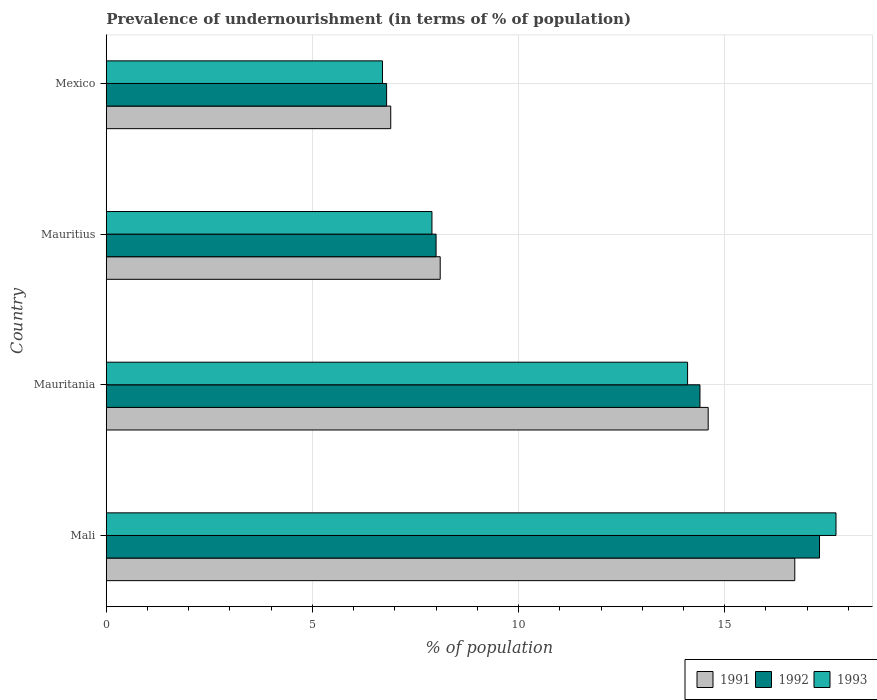How many different coloured bars are there?
Give a very brief answer. 3. How many groups of bars are there?
Offer a very short reply. 4. How many bars are there on the 4th tick from the bottom?
Provide a short and direct response. 3. What is the label of the 3rd group of bars from the top?
Provide a succinct answer. Mauritania. In which country was the percentage of undernourished population in 1992 maximum?
Your response must be concise. Mali. What is the total percentage of undernourished population in 1991 in the graph?
Your answer should be compact. 46.3. What is the difference between the percentage of undernourished population in 1992 in Mexico and the percentage of undernourished population in 1993 in Mali?
Provide a succinct answer. -10.9. What is the average percentage of undernourished population in 1992 per country?
Your answer should be very brief. 11.62. What is the difference between the percentage of undernourished population in 1993 and percentage of undernourished population in 1991 in Mexico?
Keep it short and to the point. -0.2. What is the ratio of the percentage of undernourished population in 1993 in Mali to that in Mauritius?
Offer a terse response. 2.24. Is the difference between the percentage of undernourished population in 1993 in Mali and Mauritius greater than the difference between the percentage of undernourished population in 1991 in Mali and Mauritius?
Ensure brevity in your answer.  Yes. What is the difference between the highest and the second highest percentage of undernourished population in 1993?
Give a very brief answer. 3.6. What is the difference between the highest and the lowest percentage of undernourished population in 1993?
Provide a short and direct response. 11. Is it the case that in every country, the sum of the percentage of undernourished population in 1991 and percentage of undernourished population in 1993 is greater than the percentage of undernourished population in 1992?
Your answer should be very brief. Yes. How many countries are there in the graph?
Make the answer very short. 4. What is the difference between two consecutive major ticks on the X-axis?
Provide a short and direct response. 5. How many legend labels are there?
Your answer should be compact. 3. How are the legend labels stacked?
Your response must be concise. Horizontal. What is the title of the graph?
Give a very brief answer. Prevalence of undernourishment (in terms of % of population). What is the label or title of the X-axis?
Your answer should be very brief. % of population. What is the label or title of the Y-axis?
Give a very brief answer. Country. What is the % of population of 1991 in Mali?
Keep it short and to the point. 16.7. What is the % of population in 1993 in Mali?
Your answer should be compact. 17.7. What is the % of population of 1991 in Mauritania?
Keep it short and to the point. 14.6. What is the % of population of 1993 in Mauritius?
Ensure brevity in your answer.  7.9. What is the % of population in 1991 in Mexico?
Ensure brevity in your answer.  6.9. What is the % of population of 1992 in Mexico?
Keep it short and to the point. 6.8. What is the % of population of 1993 in Mexico?
Your answer should be very brief. 6.7. Across all countries, what is the maximum % of population in 1991?
Provide a short and direct response. 16.7. What is the total % of population of 1991 in the graph?
Offer a terse response. 46.3. What is the total % of population in 1992 in the graph?
Provide a succinct answer. 46.5. What is the total % of population in 1993 in the graph?
Ensure brevity in your answer.  46.4. What is the difference between the % of population in 1993 in Mali and that in Mauritania?
Provide a succinct answer. 3.6. What is the difference between the % of population of 1991 in Mali and that in Mauritius?
Provide a short and direct response. 8.6. What is the difference between the % of population in 1992 in Mali and that in Mauritius?
Provide a short and direct response. 9.3. What is the difference between the % of population in 1992 in Mauritania and that in Mexico?
Make the answer very short. 7.6. What is the difference between the % of population of 1991 in Mauritius and that in Mexico?
Provide a succinct answer. 1.2. What is the difference between the % of population of 1992 in Mauritius and that in Mexico?
Make the answer very short. 1.2. What is the difference between the % of population in 1993 in Mauritius and that in Mexico?
Keep it short and to the point. 1.2. What is the difference between the % of population of 1991 in Mali and the % of population of 1992 in Mauritania?
Offer a terse response. 2.3. What is the difference between the % of population in 1991 in Mali and the % of population in 1993 in Mauritania?
Your answer should be very brief. 2.6. What is the difference between the % of population of 1992 in Mali and the % of population of 1993 in Mauritania?
Provide a short and direct response. 3.2. What is the difference between the % of population of 1991 in Mali and the % of population of 1993 in Mauritius?
Keep it short and to the point. 8.8. What is the difference between the % of population of 1991 in Mali and the % of population of 1992 in Mexico?
Your answer should be compact. 9.9. What is the difference between the % of population in 1991 in Mali and the % of population in 1993 in Mexico?
Offer a terse response. 10. What is the difference between the % of population in 1991 in Mauritania and the % of population in 1992 in Mauritius?
Offer a terse response. 6.6. What is the difference between the % of population in 1992 in Mauritania and the % of population in 1993 in Mauritius?
Your answer should be very brief. 6.5. What is the difference between the % of population in 1991 in Mauritania and the % of population in 1992 in Mexico?
Keep it short and to the point. 7.8. What is the difference between the % of population in 1992 in Mauritania and the % of population in 1993 in Mexico?
Your answer should be compact. 7.7. What is the average % of population in 1991 per country?
Make the answer very short. 11.57. What is the average % of population of 1992 per country?
Your answer should be compact. 11.62. What is the difference between the % of population of 1991 and % of population of 1993 in Mali?
Provide a succinct answer. -1. What is the difference between the % of population of 1992 and % of population of 1993 in Mali?
Make the answer very short. -0.4. What is the difference between the % of population of 1991 and % of population of 1992 in Mauritania?
Give a very brief answer. 0.2. What is the difference between the % of population in 1992 and % of population in 1993 in Mauritania?
Your response must be concise. 0.3. What is the difference between the % of population of 1991 and % of population of 1992 in Mauritius?
Make the answer very short. 0.1. What is the difference between the % of population in 1991 and % of population in 1993 in Mauritius?
Keep it short and to the point. 0.2. What is the difference between the % of population in 1992 and % of population in 1993 in Mauritius?
Keep it short and to the point. 0.1. What is the difference between the % of population of 1991 and % of population of 1993 in Mexico?
Provide a succinct answer. 0.2. What is the difference between the % of population in 1992 and % of population in 1993 in Mexico?
Provide a short and direct response. 0.1. What is the ratio of the % of population of 1991 in Mali to that in Mauritania?
Make the answer very short. 1.14. What is the ratio of the % of population in 1992 in Mali to that in Mauritania?
Give a very brief answer. 1.2. What is the ratio of the % of population in 1993 in Mali to that in Mauritania?
Your answer should be very brief. 1.26. What is the ratio of the % of population of 1991 in Mali to that in Mauritius?
Provide a succinct answer. 2.06. What is the ratio of the % of population of 1992 in Mali to that in Mauritius?
Your answer should be compact. 2.16. What is the ratio of the % of population in 1993 in Mali to that in Mauritius?
Make the answer very short. 2.24. What is the ratio of the % of population of 1991 in Mali to that in Mexico?
Give a very brief answer. 2.42. What is the ratio of the % of population of 1992 in Mali to that in Mexico?
Your answer should be very brief. 2.54. What is the ratio of the % of population of 1993 in Mali to that in Mexico?
Make the answer very short. 2.64. What is the ratio of the % of population in 1991 in Mauritania to that in Mauritius?
Your response must be concise. 1.8. What is the ratio of the % of population in 1992 in Mauritania to that in Mauritius?
Offer a very short reply. 1.8. What is the ratio of the % of population in 1993 in Mauritania to that in Mauritius?
Make the answer very short. 1.78. What is the ratio of the % of population of 1991 in Mauritania to that in Mexico?
Ensure brevity in your answer.  2.12. What is the ratio of the % of population of 1992 in Mauritania to that in Mexico?
Give a very brief answer. 2.12. What is the ratio of the % of population of 1993 in Mauritania to that in Mexico?
Offer a terse response. 2.1. What is the ratio of the % of population in 1991 in Mauritius to that in Mexico?
Keep it short and to the point. 1.17. What is the ratio of the % of population of 1992 in Mauritius to that in Mexico?
Provide a short and direct response. 1.18. What is the ratio of the % of population in 1993 in Mauritius to that in Mexico?
Keep it short and to the point. 1.18. What is the difference between the highest and the second highest % of population of 1991?
Provide a succinct answer. 2.1. What is the difference between the highest and the second highest % of population of 1993?
Provide a short and direct response. 3.6. What is the difference between the highest and the lowest % of population of 1992?
Your answer should be compact. 10.5. What is the difference between the highest and the lowest % of population in 1993?
Offer a terse response. 11. 